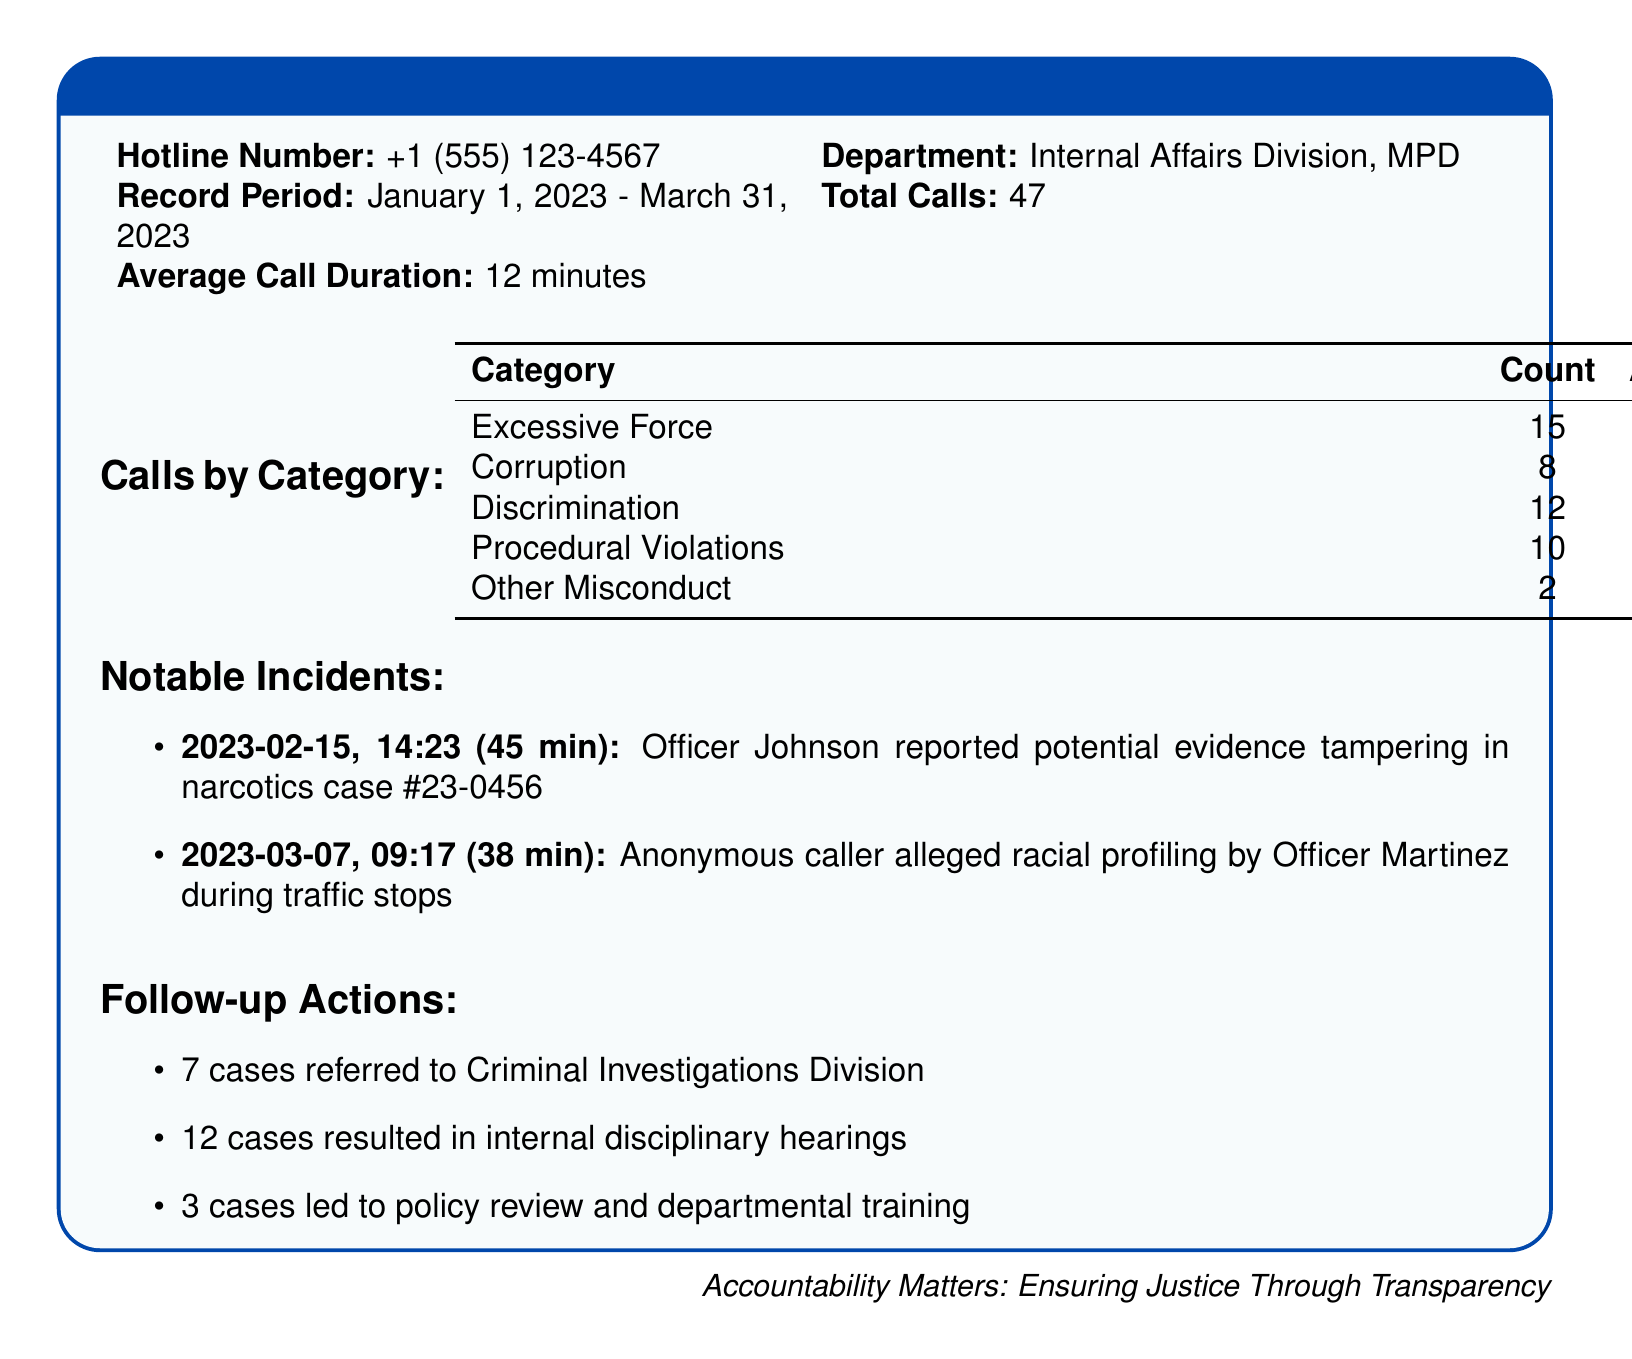what is the hotline number? The hotline number is specific information listed in the document under hotline tracking.
Answer: +1 (555) 123-4567 how many total calls were received? The total calls are clearly mentioned in the document, indicating the number of reports made through the hotline.
Answer: 47 what is the average call duration? The average call duration is provided in the document, reflecting the typical length of calls received.
Answer: 12 minutes which category received the most calls? The document categorizes calls, and the one with the highest count represents the most frequent issue reported.
Answer: Excessive Force how many cases led to policy review? This number is specifically stated in the follow-up actions section of the document, highlighting how many issues prompted a change in policy.
Answer: 3 cases what was the average duration of corruption calls? The average duration is discussed in the "Calls by Category" table, which details the time spent on each type of call.
Answer: 22 minutes what date was the report about potential evidence tampering made? The date of the notable incident regarding potential evidence tampering is listed in a specific format in the document.
Answer: 2023-02-15 how many cases resulted in internal disciplinary hearings? This number indicates the results of the actions taken following the calls and is provided in the follow-up actions section.
Answer: 12 cases what was the nature of the 2023-03-07 call? The nature of the call is described under notable incidents, detailing the allegations made.
Answer: Racial profiling 